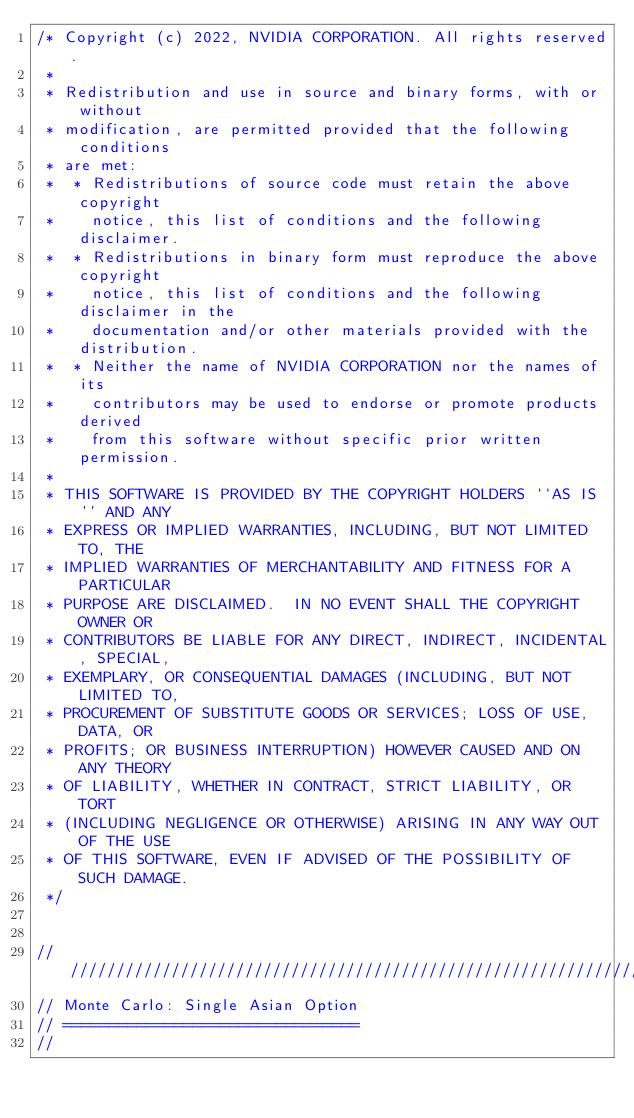<code> <loc_0><loc_0><loc_500><loc_500><_C++_>/* Copyright (c) 2022, NVIDIA CORPORATION. All rights reserved.
 *
 * Redistribution and use in source and binary forms, with or without
 * modification, are permitted provided that the following conditions
 * are met:
 *  * Redistributions of source code must retain the above copyright
 *    notice, this list of conditions and the following disclaimer.
 *  * Redistributions in binary form must reproduce the above copyright
 *    notice, this list of conditions and the following disclaimer in the
 *    documentation and/or other materials provided with the distribution.
 *  * Neither the name of NVIDIA CORPORATION nor the names of its
 *    contributors may be used to endorse or promote products derived
 *    from this software without specific prior written permission.
 *
 * THIS SOFTWARE IS PROVIDED BY THE COPYRIGHT HOLDERS ``AS IS'' AND ANY
 * EXPRESS OR IMPLIED WARRANTIES, INCLUDING, BUT NOT LIMITED TO, THE
 * IMPLIED WARRANTIES OF MERCHANTABILITY AND FITNESS FOR A PARTICULAR
 * PURPOSE ARE DISCLAIMED.  IN NO EVENT SHALL THE COPYRIGHT OWNER OR
 * CONTRIBUTORS BE LIABLE FOR ANY DIRECT, INDIRECT, INCIDENTAL, SPECIAL,
 * EXEMPLARY, OR CONSEQUENTIAL DAMAGES (INCLUDING, BUT NOT LIMITED TO,
 * PROCUREMENT OF SUBSTITUTE GOODS OR SERVICES; LOSS OF USE, DATA, OR
 * PROFITS; OR BUSINESS INTERRUPTION) HOWEVER CAUSED AND ON ANY THEORY
 * OF LIABILITY, WHETHER IN CONTRACT, STRICT LIABILITY, OR TORT
 * (INCLUDING NEGLIGENCE OR OTHERWISE) ARISING IN ANY WAY OUT OF THE USE
 * OF THIS SOFTWARE, EVEN IF ADVISED OF THE POSSIBILITY OF SUCH DAMAGE.
 */


///////////////////////////////////////////////////////////////////////////////
// Monte Carlo: Single Asian Option
// ================================
//</code> 